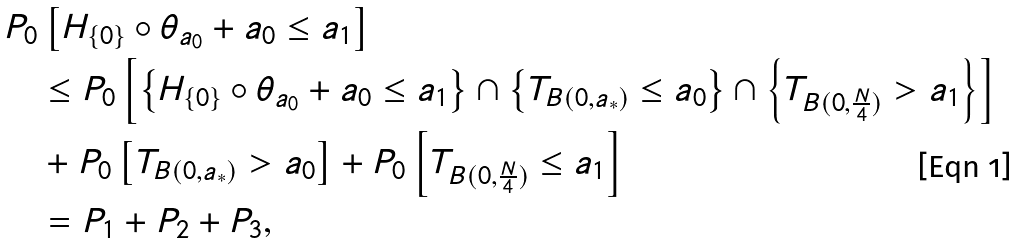<formula> <loc_0><loc_0><loc_500><loc_500>& P _ { 0 } \left [ H _ { \{ 0 \} } \circ \theta _ { a _ { 0 } } + a _ { 0 } \leq a _ { 1 } \right ] \\ & \quad \leq P _ { 0 } \left [ \left \{ H _ { \{ 0 \} } \circ \theta _ { a _ { 0 } } + a _ { 0 } \leq a _ { 1 } \right \} \cap \left \{ T _ { B ( 0 , a _ { * } ) } \leq a _ { 0 } \right \} \cap \left \{ T _ { B ( 0 , \frac { N } { 4 } ) } > a _ { 1 } \right \} \right ] \\ & \quad + P _ { 0 } \left [ T _ { B ( 0 , a _ { * } ) } > a _ { 0 } \right ] + P _ { 0 } \left [ T _ { B ( 0 , \frac { N } { 4 } ) } \leq a _ { 1 } \right ] \\ & \quad = P _ { 1 } + P _ { 2 } + P _ { 3 } ,</formula> 